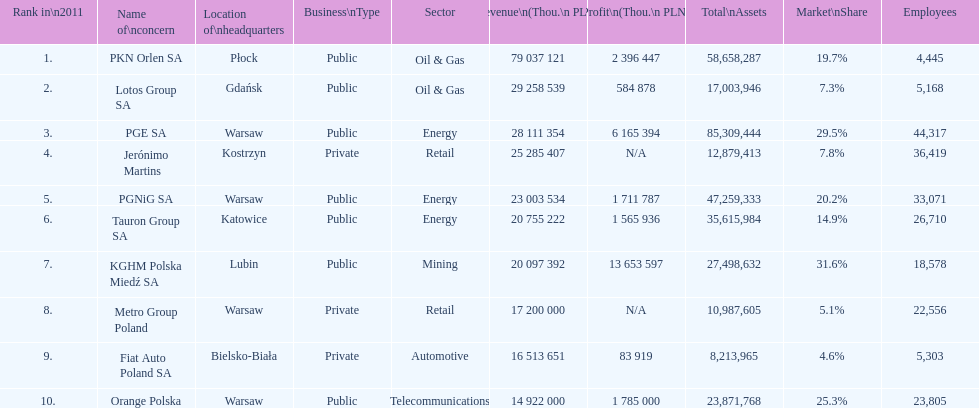What is the difference in employees for rank 1 and rank 3? 39,872 employees. 